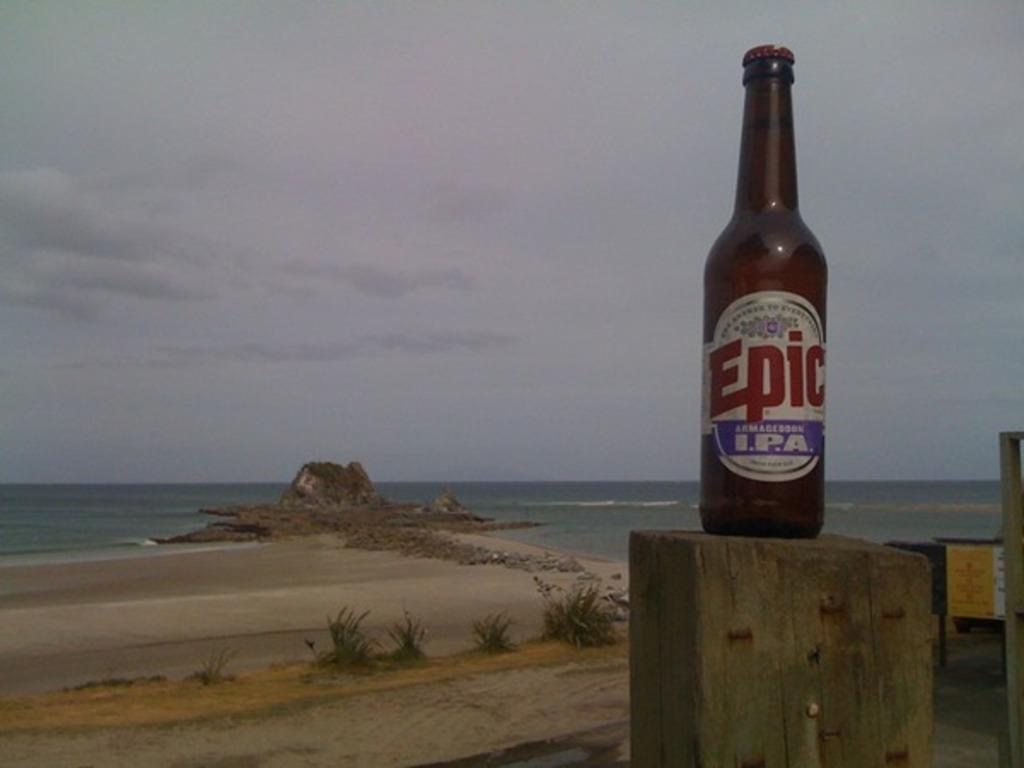<image>
Present a compact description of the photo's key features. With the ocean and beach in the back ground a wooden post has a bottle of Epic brand beer sitting on it. 